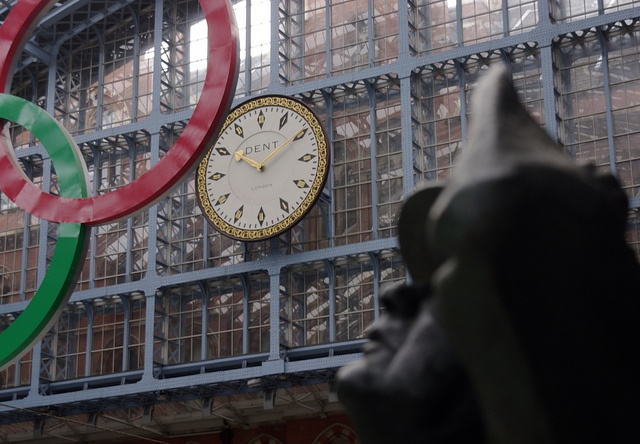Describe the objects in this image and their specific colors. I can see people in black and gray tones and clock in black, darkgray, tan, and gray tones in this image. 